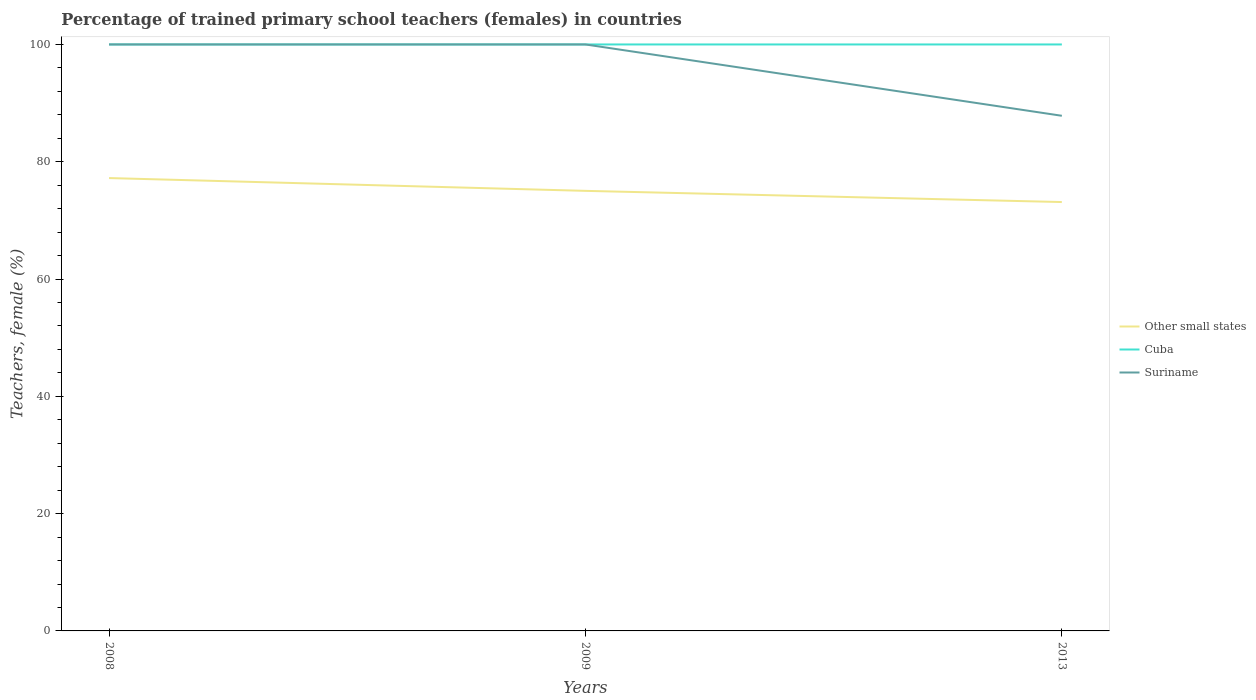Does the line corresponding to Cuba intersect with the line corresponding to Suriname?
Provide a succinct answer. Yes. In which year was the percentage of trained primary school teachers (females) in Suriname maximum?
Offer a terse response. 2013. What is the total percentage of trained primary school teachers (females) in Cuba in the graph?
Provide a succinct answer. 0. What is the difference between the highest and the second highest percentage of trained primary school teachers (females) in Suriname?
Your response must be concise. 12.16. Is the percentage of trained primary school teachers (females) in Suriname strictly greater than the percentage of trained primary school teachers (females) in Cuba over the years?
Your answer should be very brief. No. What is the difference between two consecutive major ticks on the Y-axis?
Your answer should be compact. 20. Are the values on the major ticks of Y-axis written in scientific E-notation?
Give a very brief answer. No. Does the graph contain any zero values?
Keep it short and to the point. No. Where does the legend appear in the graph?
Your answer should be very brief. Center right. What is the title of the graph?
Provide a succinct answer. Percentage of trained primary school teachers (females) in countries. Does "Angola" appear as one of the legend labels in the graph?
Your response must be concise. No. What is the label or title of the X-axis?
Provide a short and direct response. Years. What is the label or title of the Y-axis?
Provide a short and direct response. Teachers, female (%). What is the Teachers, female (%) in Other small states in 2008?
Offer a terse response. 77.22. What is the Teachers, female (%) of Other small states in 2009?
Your response must be concise. 75.04. What is the Teachers, female (%) of Cuba in 2009?
Offer a very short reply. 100. What is the Teachers, female (%) in Suriname in 2009?
Offer a very short reply. 100. What is the Teachers, female (%) in Other small states in 2013?
Offer a very short reply. 73.13. What is the Teachers, female (%) in Suriname in 2013?
Your answer should be compact. 87.84. Across all years, what is the maximum Teachers, female (%) in Other small states?
Your answer should be compact. 77.22. Across all years, what is the maximum Teachers, female (%) of Cuba?
Offer a terse response. 100. Across all years, what is the minimum Teachers, female (%) of Other small states?
Offer a very short reply. 73.13. Across all years, what is the minimum Teachers, female (%) in Suriname?
Provide a short and direct response. 87.84. What is the total Teachers, female (%) in Other small states in the graph?
Offer a terse response. 225.38. What is the total Teachers, female (%) of Cuba in the graph?
Keep it short and to the point. 300. What is the total Teachers, female (%) in Suriname in the graph?
Provide a succinct answer. 287.84. What is the difference between the Teachers, female (%) in Other small states in 2008 and that in 2009?
Offer a terse response. 2.18. What is the difference between the Teachers, female (%) of Cuba in 2008 and that in 2009?
Keep it short and to the point. 0. What is the difference between the Teachers, female (%) in Other small states in 2008 and that in 2013?
Provide a succinct answer. 4.09. What is the difference between the Teachers, female (%) of Suriname in 2008 and that in 2013?
Ensure brevity in your answer.  12.16. What is the difference between the Teachers, female (%) of Other small states in 2009 and that in 2013?
Your response must be concise. 1.91. What is the difference between the Teachers, female (%) of Suriname in 2009 and that in 2013?
Ensure brevity in your answer.  12.16. What is the difference between the Teachers, female (%) in Other small states in 2008 and the Teachers, female (%) in Cuba in 2009?
Give a very brief answer. -22.78. What is the difference between the Teachers, female (%) in Other small states in 2008 and the Teachers, female (%) in Suriname in 2009?
Offer a very short reply. -22.78. What is the difference between the Teachers, female (%) in Other small states in 2008 and the Teachers, female (%) in Cuba in 2013?
Ensure brevity in your answer.  -22.78. What is the difference between the Teachers, female (%) of Other small states in 2008 and the Teachers, female (%) of Suriname in 2013?
Make the answer very short. -10.62. What is the difference between the Teachers, female (%) of Cuba in 2008 and the Teachers, female (%) of Suriname in 2013?
Ensure brevity in your answer.  12.16. What is the difference between the Teachers, female (%) of Other small states in 2009 and the Teachers, female (%) of Cuba in 2013?
Provide a succinct answer. -24.96. What is the difference between the Teachers, female (%) in Other small states in 2009 and the Teachers, female (%) in Suriname in 2013?
Your answer should be very brief. -12.8. What is the difference between the Teachers, female (%) of Cuba in 2009 and the Teachers, female (%) of Suriname in 2013?
Your response must be concise. 12.16. What is the average Teachers, female (%) of Other small states per year?
Provide a short and direct response. 75.13. What is the average Teachers, female (%) of Suriname per year?
Ensure brevity in your answer.  95.95. In the year 2008, what is the difference between the Teachers, female (%) of Other small states and Teachers, female (%) of Cuba?
Make the answer very short. -22.78. In the year 2008, what is the difference between the Teachers, female (%) in Other small states and Teachers, female (%) in Suriname?
Ensure brevity in your answer.  -22.78. In the year 2009, what is the difference between the Teachers, female (%) of Other small states and Teachers, female (%) of Cuba?
Make the answer very short. -24.96. In the year 2009, what is the difference between the Teachers, female (%) of Other small states and Teachers, female (%) of Suriname?
Provide a succinct answer. -24.96. In the year 2009, what is the difference between the Teachers, female (%) in Cuba and Teachers, female (%) in Suriname?
Your answer should be very brief. 0. In the year 2013, what is the difference between the Teachers, female (%) of Other small states and Teachers, female (%) of Cuba?
Make the answer very short. -26.87. In the year 2013, what is the difference between the Teachers, female (%) in Other small states and Teachers, female (%) in Suriname?
Ensure brevity in your answer.  -14.71. In the year 2013, what is the difference between the Teachers, female (%) in Cuba and Teachers, female (%) in Suriname?
Your answer should be very brief. 12.16. What is the ratio of the Teachers, female (%) of Other small states in 2008 to that in 2009?
Provide a succinct answer. 1.03. What is the ratio of the Teachers, female (%) of Other small states in 2008 to that in 2013?
Your answer should be very brief. 1.06. What is the ratio of the Teachers, female (%) of Cuba in 2008 to that in 2013?
Your response must be concise. 1. What is the ratio of the Teachers, female (%) of Suriname in 2008 to that in 2013?
Keep it short and to the point. 1.14. What is the ratio of the Teachers, female (%) in Other small states in 2009 to that in 2013?
Provide a short and direct response. 1.03. What is the ratio of the Teachers, female (%) in Cuba in 2009 to that in 2013?
Give a very brief answer. 1. What is the ratio of the Teachers, female (%) in Suriname in 2009 to that in 2013?
Give a very brief answer. 1.14. What is the difference between the highest and the second highest Teachers, female (%) in Other small states?
Make the answer very short. 2.18. What is the difference between the highest and the second highest Teachers, female (%) in Cuba?
Give a very brief answer. 0. What is the difference between the highest and the second highest Teachers, female (%) in Suriname?
Your response must be concise. 0. What is the difference between the highest and the lowest Teachers, female (%) in Other small states?
Your answer should be compact. 4.09. What is the difference between the highest and the lowest Teachers, female (%) of Cuba?
Your answer should be very brief. 0. What is the difference between the highest and the lowest Teachers, female (%) of Suriname?
Your answer should be compact. 12.16. 